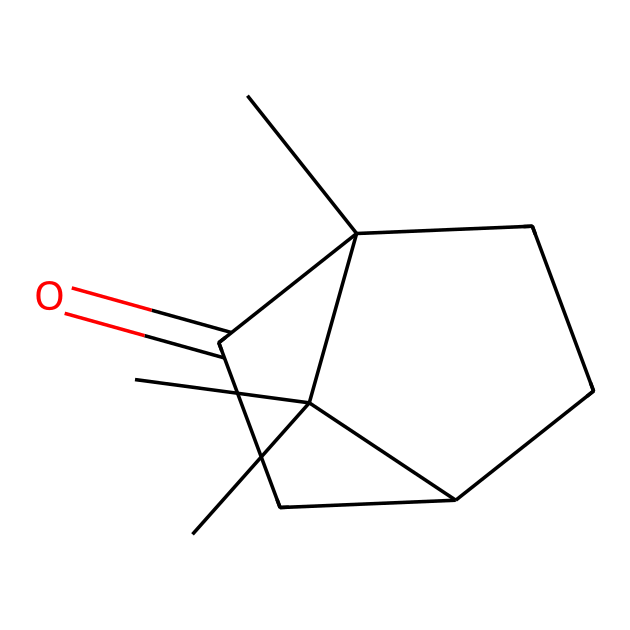What is the molecular formula of camphor? The SMILES representation indicates a total of 10 carbon atoms (C), 16 hydrogen atoms (H), and 1 oxygen atom (O) based on the structure. Therefore, the molecular formula can be derived as C10H16O.
Answer: C10H16O How many rings are present in the camphor structure? Analyzing the cyclic components in the SMILES, there are two cyclic structures indicated by the numbers '1' and '2'. Thus, there are two rings in the molecular structure of camphor.
Answer: 2 What type of functional group is present in camphor? The presence of the C=O (carbonyl) group, as indicated in the SMILES, confirms that camphor contains a ketone functional group.
Answer: ketone What is the total number of carbon atoms in the structure? By evaluating the SMILES representation, the total number of carbon atoms can be counted directly from the structure, which shows that there are 10 carbon atoms.
Answer: 10 Is camphor classified as a saturated or unsaturated ketone? Examination of the structure shows double bonds between carbon atoms, indicating that camphor is unsaturated.
Answer: unsaturated What is the oxidation state of the carbonyl carbon in camphor? In ketones, the carbonyl carbon has an oxidation state of +2, based on its bonding to another carbon atom and an oxygen atom through a double bond.
Answer: +2 